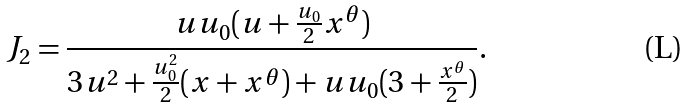<formula> <loc_0><loc_0><loc_500><loc_500>J _ { 2 } = \frac { u u _ { 0 } ( u + \frac { u _ { 0 } } { 2 } x ^ { \theta } ) } { 3 u ^ { 2 } + \frac { u ^ { 2 } _ { 0 } } { 2 } ( x + x ^ { \theta } ) + u u _ { 0 } ( 3 + \frac { x ^ { \theta } } { 2 } ) } .</formula> 